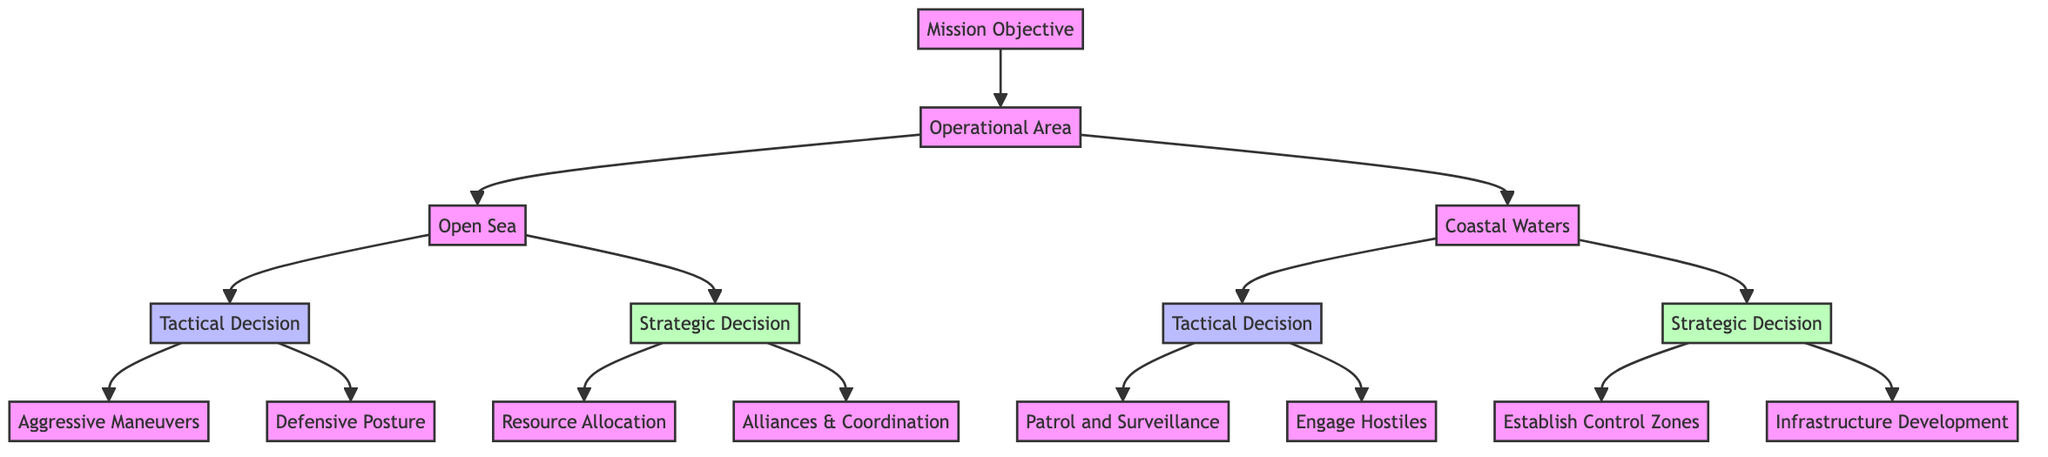What is the first decision point in the diagram? The first decision point is "Mission Objective," which is the root of the decision tree and indicates the initial basis for decision-making.
Answer: Mission Objective How many operational areas are specified in the diagram? The diagram specifies two operational areas: "Open Sea" and "Coastal Waters." There are two nodes under "Operational Area."
Answer: 2 What type of decision is associated with "Aggressive Maneuvers"? "Aggressive Maneuvers" is categorized as a "Tactical Decision," which focuses on immediate responses to threats in a predetermined operational area.
Answer: Tactical Decision What example is given for "Resource Allocation"? The example provided for "Resource Allocation" is "Logistical planning for the Pacific campaigns in World War II," illustrating the strategic distribution of resources for long-term goals.
Answer: Logistical planning for the Pacific campaigns in World War II What is the second tactical option under "Coastal Waters"? The second tactical option under "Coastal Waters" is "Engage Hostiles," which involves direct engagement with threats in that specific operational area.
Answer: Engage Hostiles Which decision type corresponds to "Establish Control Zones"? "Establish Control Zones" corresponds to the "Strategic Decision" type, indicating a focus on longer-term control and dominance in military operations.
Answer: Strategic Decision How do "Patrol and Surveillance" and "Aggressive Maneuvers" differ in terms of operational focus? "Patrol and Surveillance" focuses on gathering intelligence through routine actions, while "Aggressive Maneuvers" emphasizes immediate aggressive actions for neutralizing threats. This differentiation showcases the contrasting operational focuses within Tactical Decisions.
Answer: They differ in operational focus: intelligence gathering vs. aggressive action What operational area involves “Naval blockades used during the Cuban Missile Crisis”? The operational area involved with "Naval blockades used during the Cuban Missile Crisis" is "Coastal Waters," as it addresses control and dominance in coastal regions through strategic measures.
Answer: Coastal Waters What are the two examples given for "Alliances & Coordination"? The examples given for "Alliances & Coordination" include "Collaborate with allied forces for joint operations" and "Combined naval operations between the US and UK fleets," indicating cooperative military strategies.
Answer: Collaborate with allied forces for joint operations; Combined naval operations between the US and UK fleets 